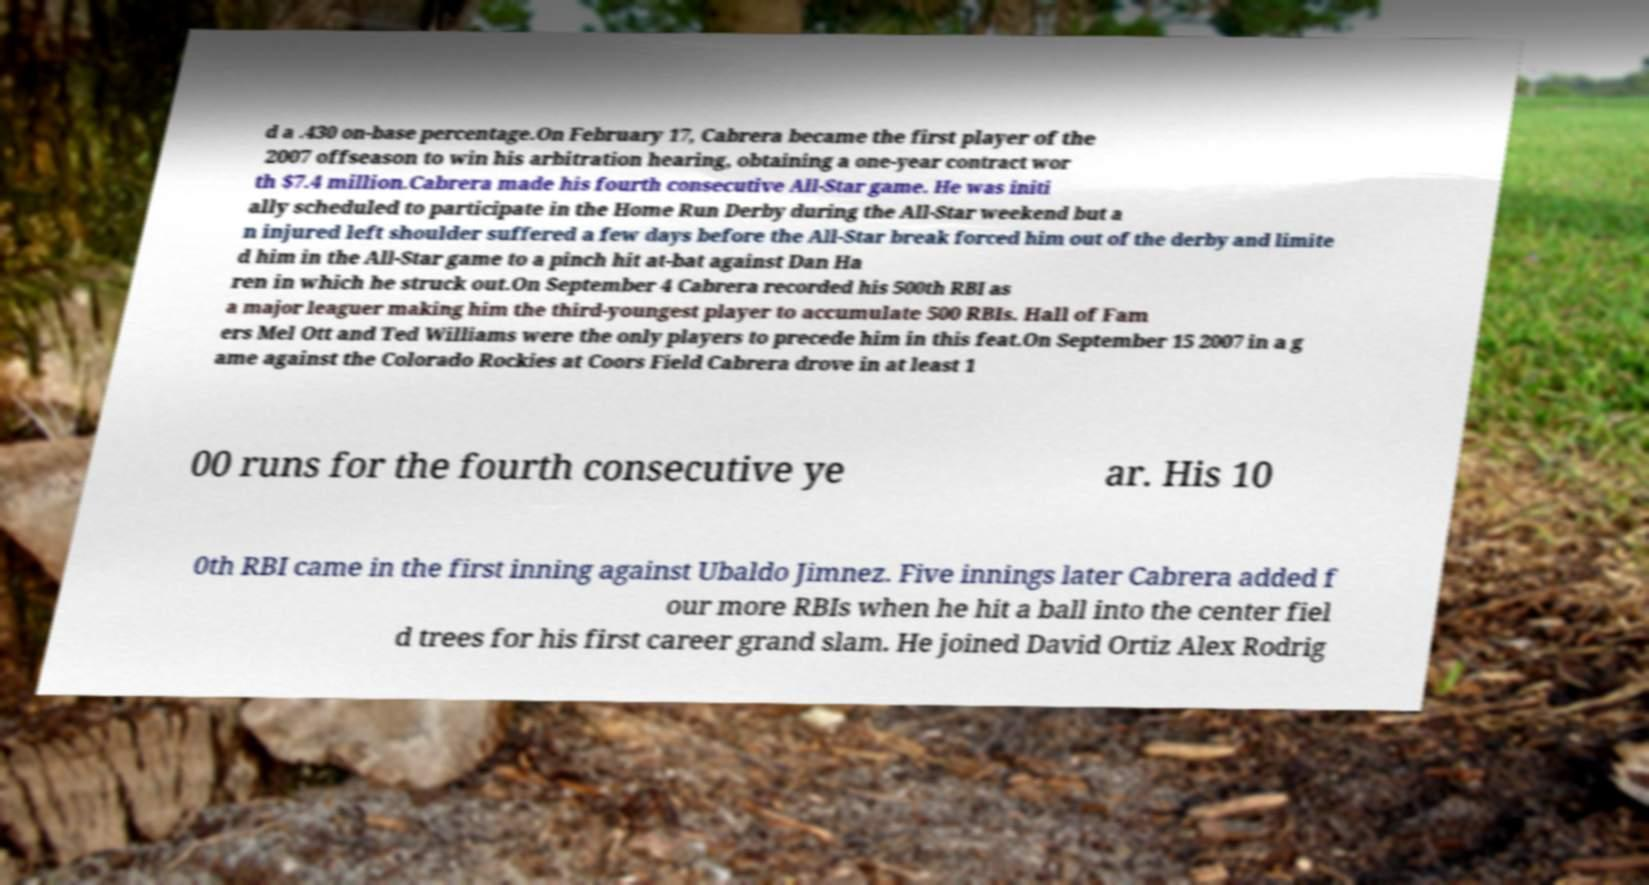Please read and relay the text visible in this image. What does it say? d a .430 on-base percentage.On February 17, Cabrera became the first player of the 2007 offseason to win his arbitration hearing, obtaining a one-year contract wor th $7.4 million.Cabrera made his fourth consecutive All-Star game. He was initi ally scheduled to participate in the Home Run Derby during the All-Star weekend but a n injured left shoulder suffered a few days before the All-Star break forced him out of the derby and limite d him in the All-Star game to a pinch hit at-bat against Dan Ha ren in which he struck out.On September 4 Cabrera recorded his 500th RBI as a major leaguer making him the third-youngest player to accumulate 500 RBIs. Hall of Fam ers Mel Ott and Ted Williams were the only players to precede him in this feat.On September 15 2007 in a g ame against the Colorado Rockies at Coors Field Cabrera drove in at least 1 00 runs for the fourth consecutive ye ar. His 10 0th RBI came in the first inning against Ubaldo Jimnez. Five innings later Cabrera added f our more RBIs when he hit a ball into the center fiel d trees for his first career grand slam. He joined David Ortiz Alex Rodrig 